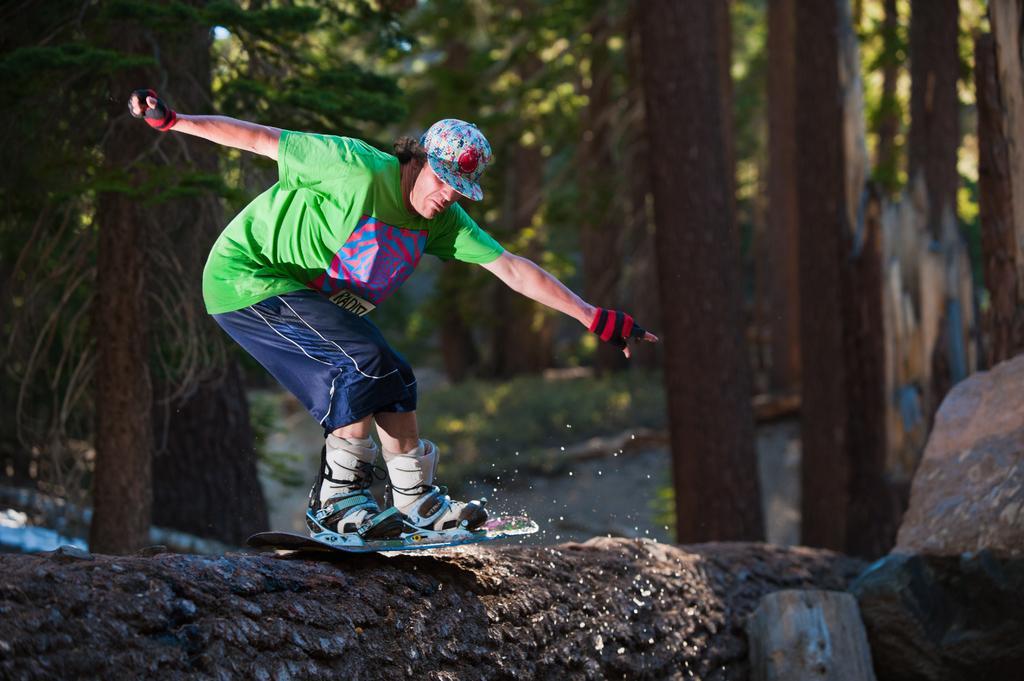Can you describe this image briefly? In this picture we can see a person wore a cap, gloves, shoes and skating with a skateboard on a platform and in the background we can see trees. 